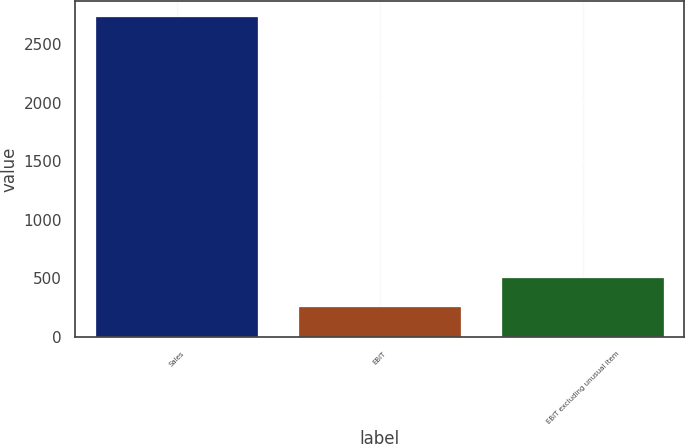Convert chart. <chart><loc_0><loc_0><loc_500><loc_500><bar_chart><fcel>Sales<fcel>EBIT<fcel>EBIT excluding unusual item<nl><fcel>2728<fcel>255<fcel>502.3<nl></chart> 